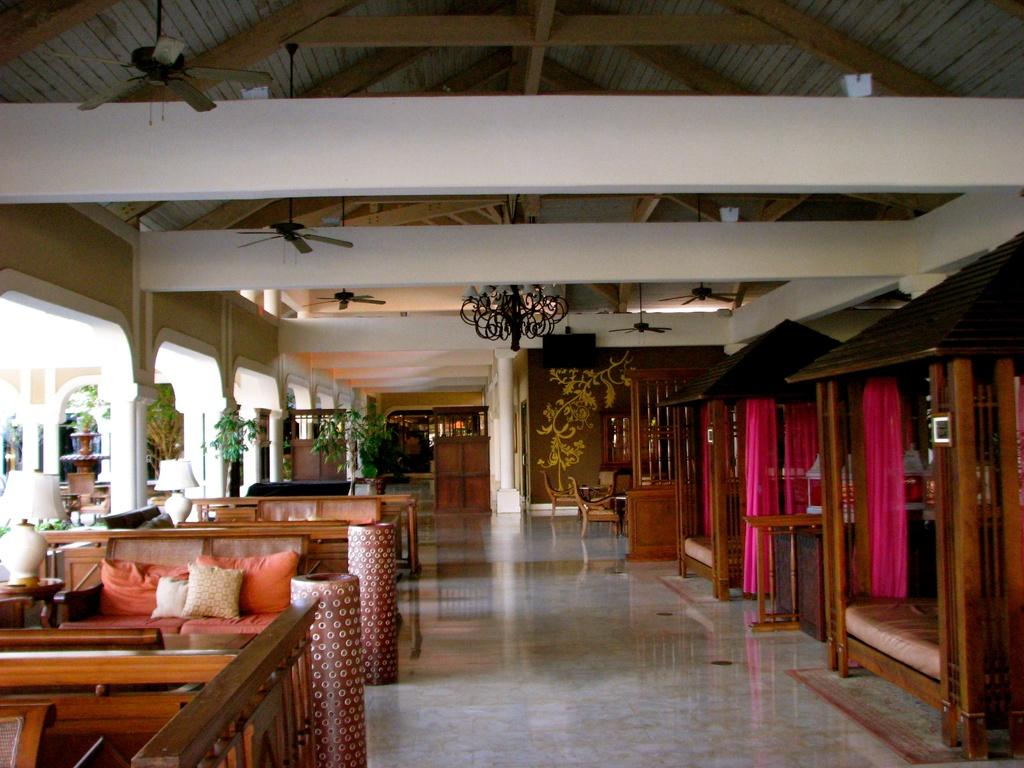What type of furniture is present in the image? There are tables, sofas, and beds in the image. What type of window treatment is visible in the image? There are curtains in the image. What is placed on the tables in the image? There are lights on the tables in the image. What type of appliance is present in the image? There are fans in the image. What type of greenery is visible in the image? There are plants in the image. Is there a partner visible in the image? There is no partner visible in the image. Is there a battle scene taking place in the image? There is no battle scene taking place in the image. Is there a box visible in the image? There is no box visible in the image. 